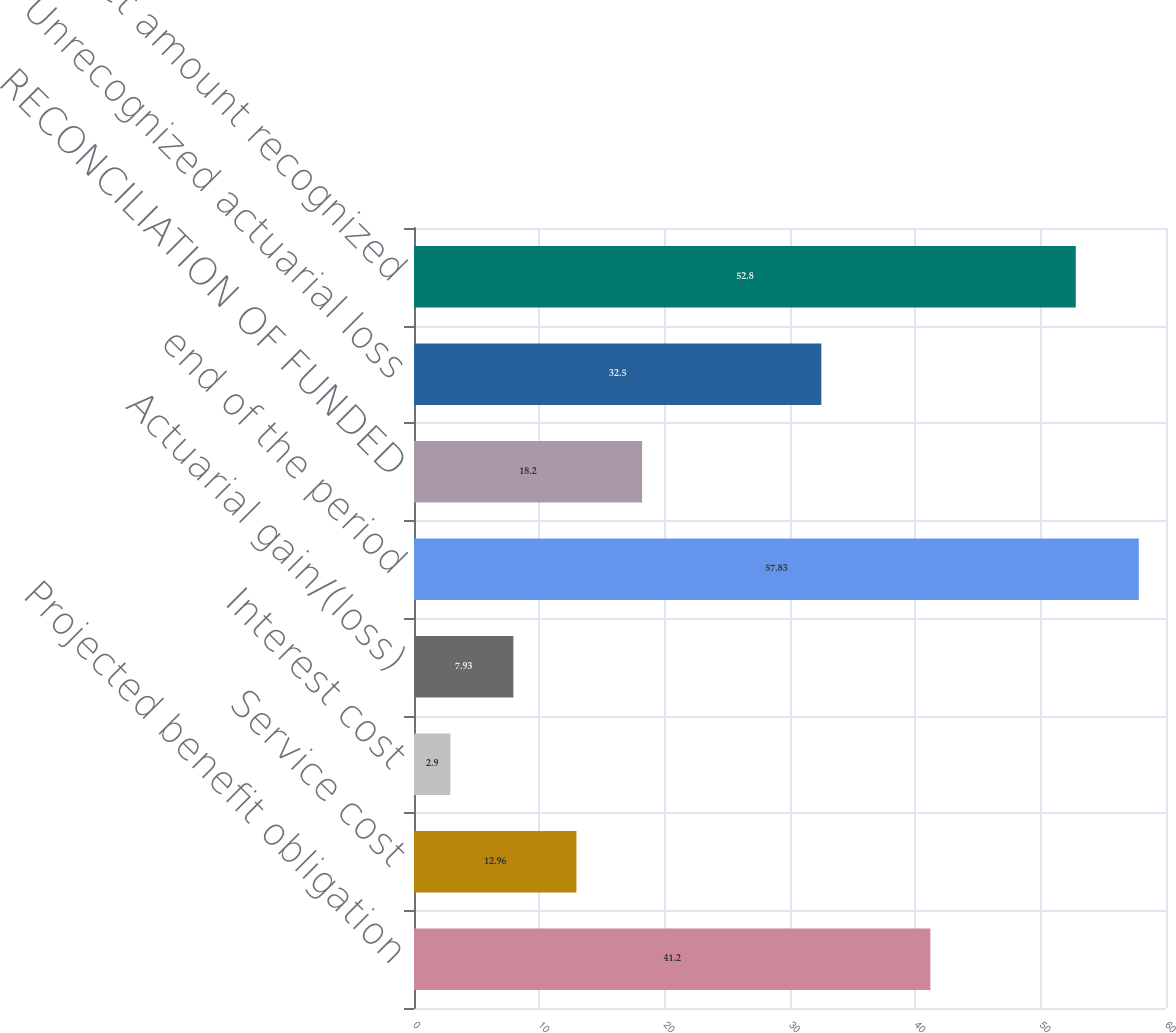<chart> <loc_0><loc_0><loc_500><loc_500><bar_chart><fcel>Projected benefit obligation<fcel>Service cost<fcel>Interest cost<fcel>Actuarial gain/(loss)<fcel>end of the period<fcel>RECONCILIATION OF FUNDED<fcel>Unrecognized actuarial loss<fcel>Net amount recognized<nl><fcel>41.2<fcel>12.96<fcel>2.9<fcel>7.93<fcel>57.83<fcel>18.2<fcel>32.5<fcel>52.8<nl></chart> 